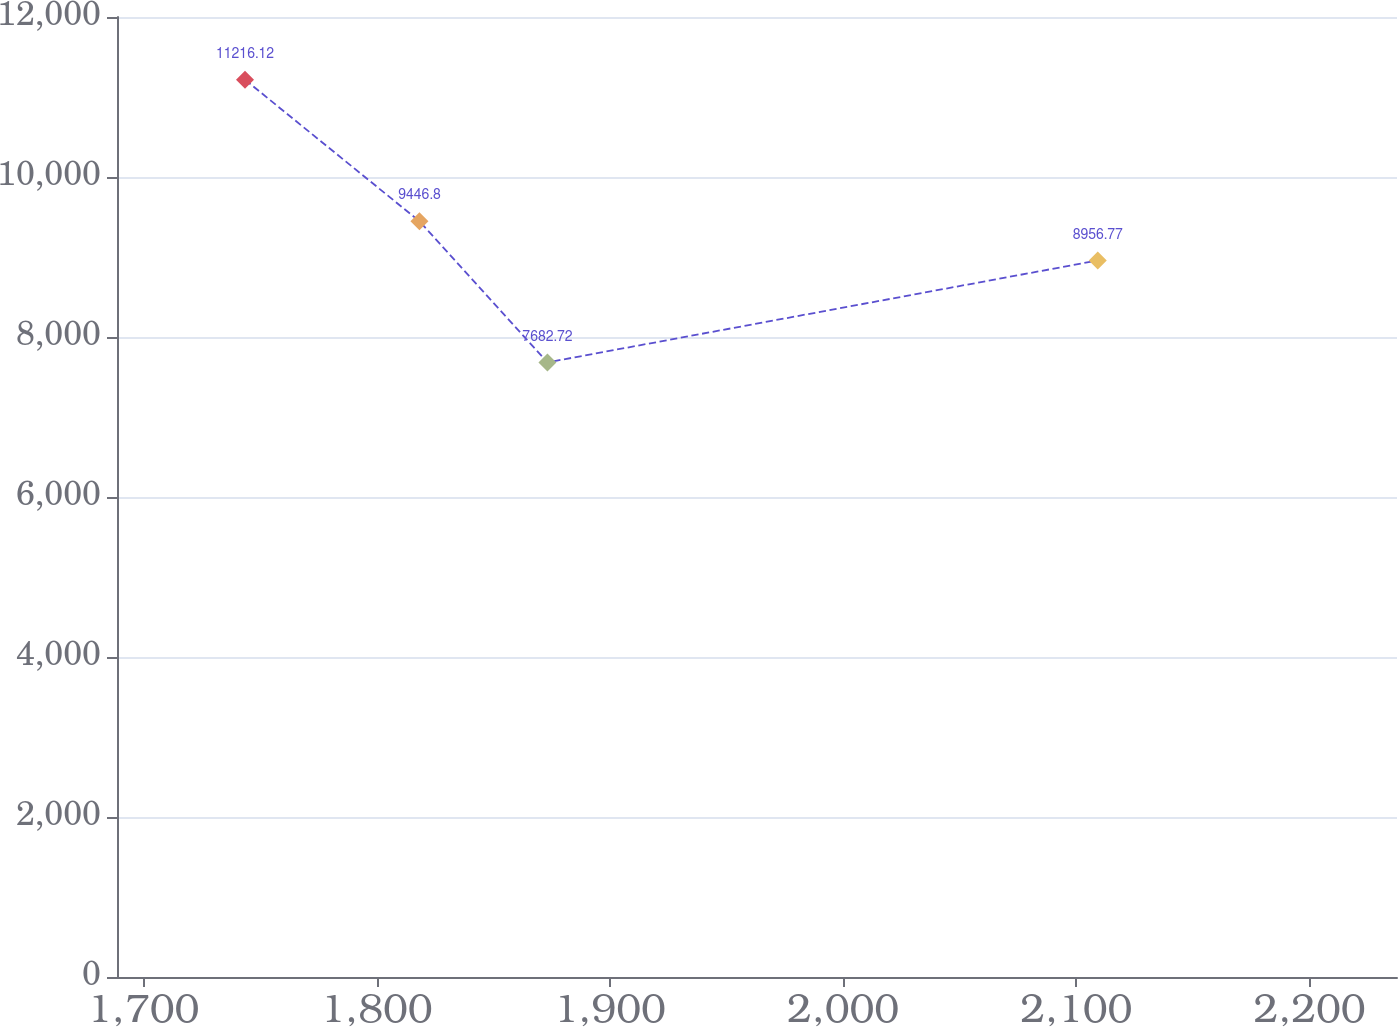<chart> <loc_0><loc_0><loc_500><loc_500><line_chart><ecel><fcel>Unnamed: 1<nl><fcel>1743.6<fcel>11216.1<nl><fcel>1818.39<fcel>9446.8<nl><fcel>1873.26<fcel>7682.72<nl><fcel>2109.18<fcel>8956.77<nl><fcel>2292.34<fcel>6315.78<nl></chart> 